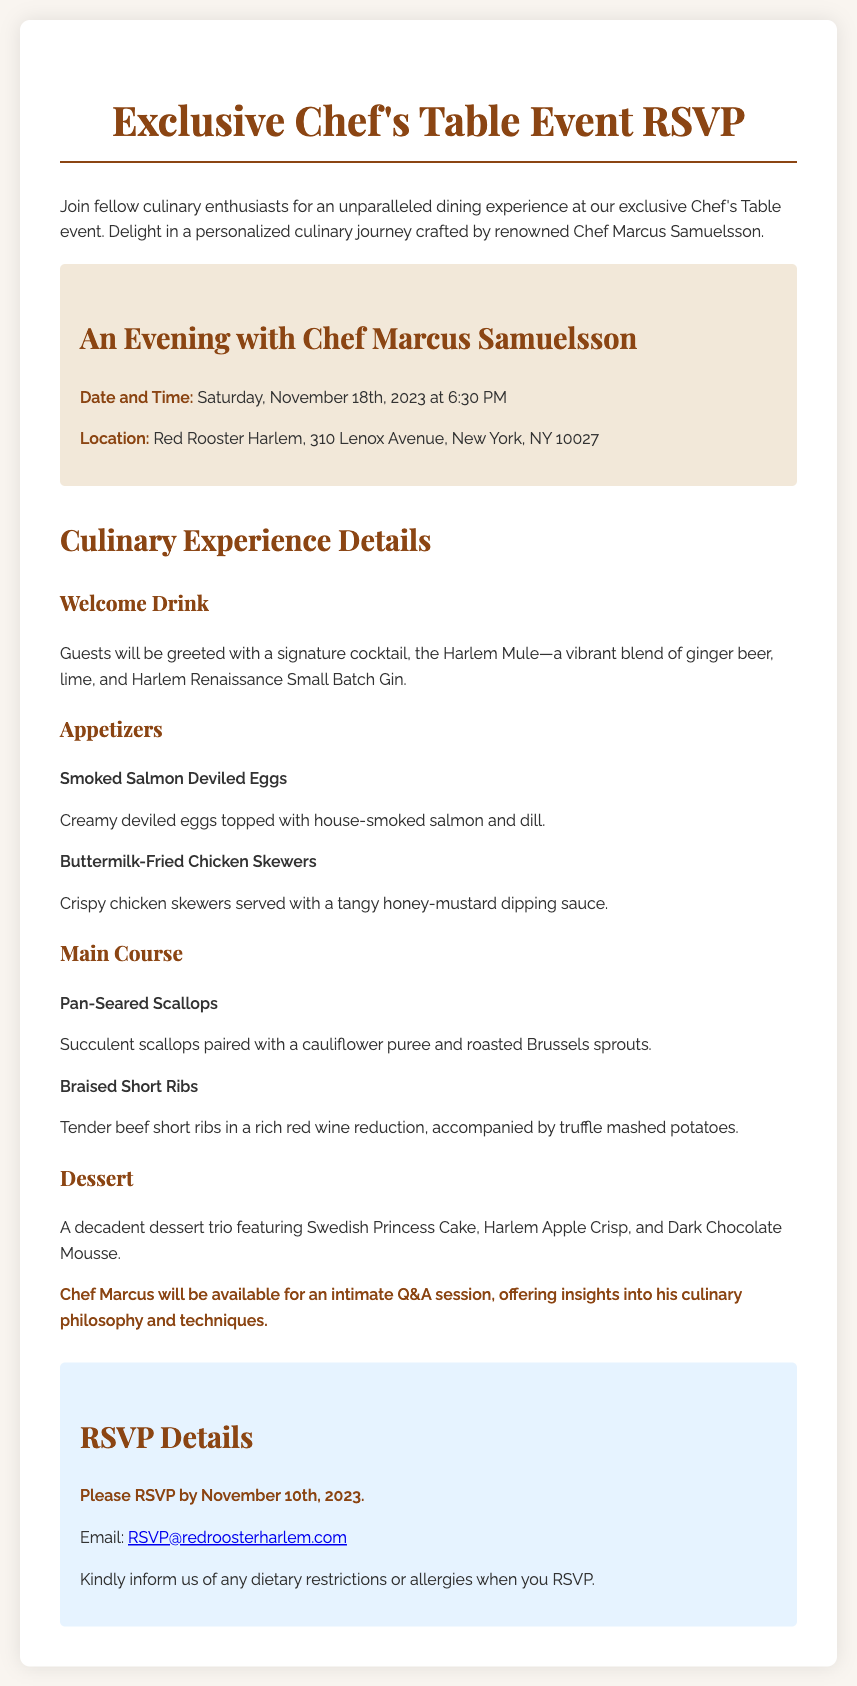what is the date of the event? The date of the event is specified in the document, which is Saturday, November 18th, 2023.
Answer: Saturday, November 18th, 2023 what is the name of the chef? The name of the chef hosting the event is given in the document. The renowned chef is Marcus Samuelsson.
Answer: Marcus Samuelsson where is the location of the event? The location of the event is outlined in the document under event details, which is Red Rooster Harlem, 310 Lenox Avenue, New York, NY 10027.
Answer: Red Rooster Harlem, 310 Lenox Avenue, New York, NY 10027 what is included in the dessert menu? The dessert menu includes three specific items mentioned in the document: Swedish Princess Cake, Harlem Apple Crisp, and Dark Chocolate Mousse.
Answer: Swedish Princess Cake, Harlem Apple Crisp, and Dark Chocolate Mousse what must guests inform when they RSVP? The RSVP section highlights what guests should inform, which are dietary restrictions or allergies when they RSVP.
Answer: Dietary restrictions or allergies what is the deadline to RSVP? The RSVP deadline is clearly stated in the document as November 10th, 2023.
Answer: November 10th, 2023 what type of drink will guests receive upon arrival? The welcome drink offered to guests is identified in the document as the Harlem Mule.
Answer: Harlem Mule what kind of session will Chef Marcus hold during the event? The document specifies that Chef Marcus will hold an intimate Q&A session during the event.
Answer: Intimate Q&A session 